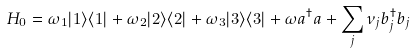Convert formula to latex. <formula><loc_0><loc_0><loc_500><loc_500>H _ { 0 } = \omega _ { 1 } | 1 \rangle \langle 1 | + \omega _ { 2 } | 2 \rangle \langle 2 | + \omega _ { 3 } | 3 \rangle \langle 3 | + \omega a ^ { \dag } a + \sum _ { j } \nu _ { j } b _ { j } ^ { \dag } b _ { j }</formula> 